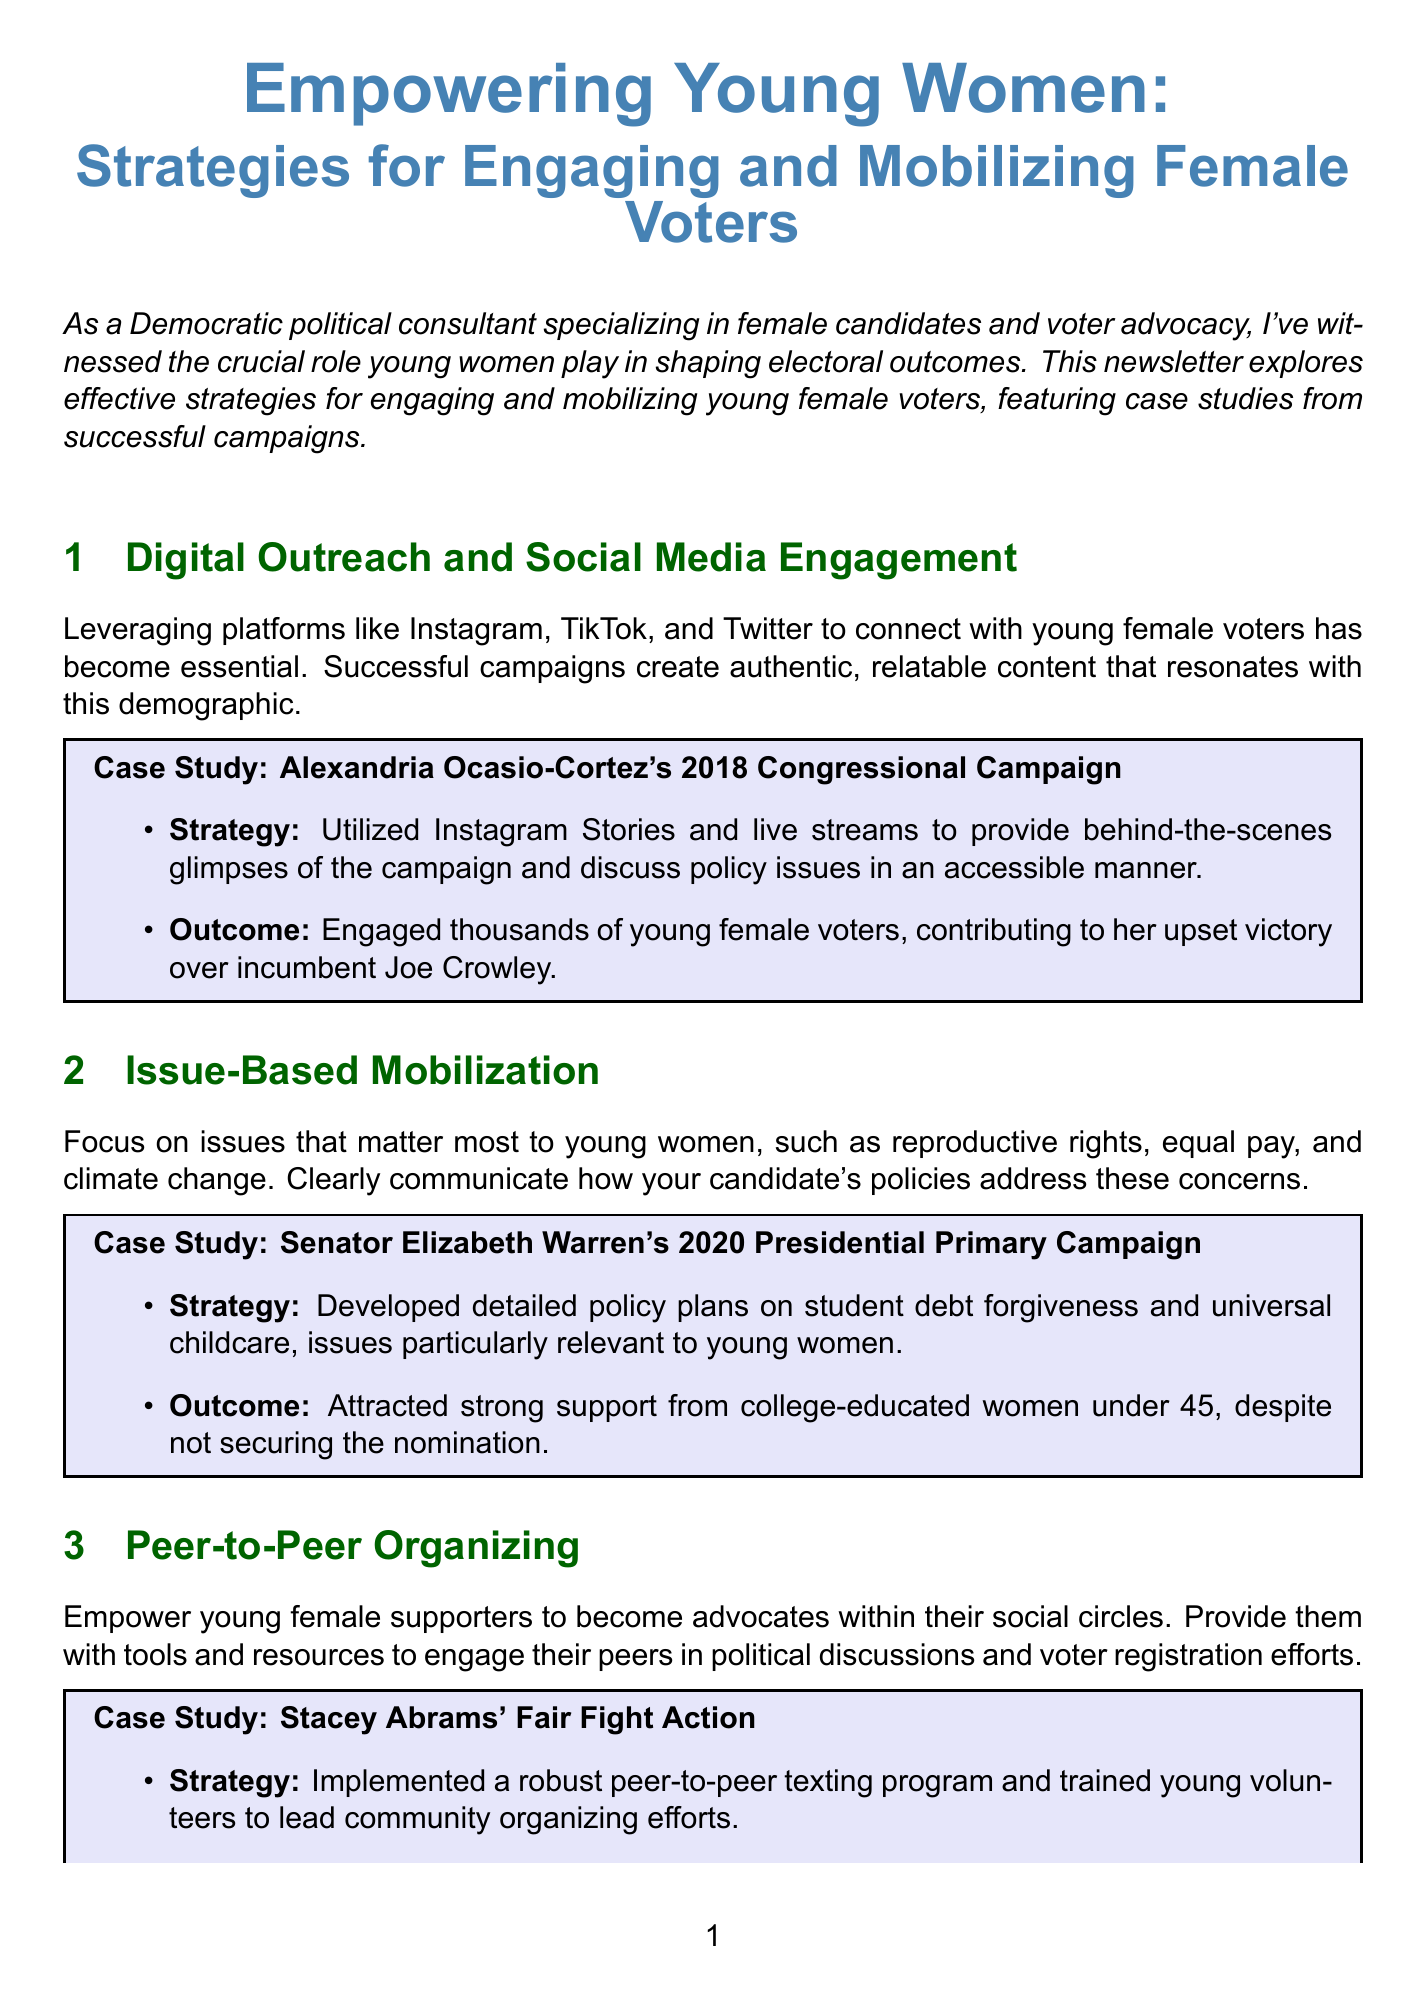What is the title of the newsletter? The title of the newsletter is stated at the beginning, highlighting its main focus on young women voters.
Answer: Empowering Young Women: Strategies for Engaging and Mobilizing Female Voters Which candidate's 2018 Congressional Campaign is used as a case study for Digital Outreach? This question references the specific case study provided in the Digital Outreach section of the document.
Answer: Alexandria Ocasio-Cortez What issue did Senator Elizabeth Warren's campaign focus on for young women? The document specifically mentions key issues that were highlighted in her campaign, particularly relevant to young women.
Answer: Student debt forgiveness How many new voters did Stacey Abrams' Fair Fight Action register? The document provides a specific number of new voters registered, highlighting the impact of the campaign's strategies.
Answer: 800,000 What term describes the approach taken to recognize diverse experiences among young women? This refers to a specific strategy mentioned in the Intersectional Approach section of the newsletter.
Answer: Intersectional Approach What type of events does the newsletter suggest hosting for young female voters? This relates to the actionable tips provided for effective engagement with the target demographic in the newsletter.
Answer: Virtual town halls Name one organization focused on young women's leadership mentioned in the actionable tips. The newsletter lists organizations that can be partnered with to enhance outreach to young women.
Answer: IGNITE National What demographic was particularly attracted to Senator Elizabeth Warren's campaign according to the document? This question pertains to specific voter characteristics highlighted in the case study of her campaign strategy.
Answer: College-educated women under 45 